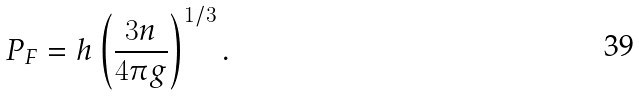<formula> <loc_0><loc_0><loc_500><loc_500>P _ { F } = h \left ( \frac { 3 n } { 4 \pi g } \right ) ^ { 1 / 3 } .</formula> 